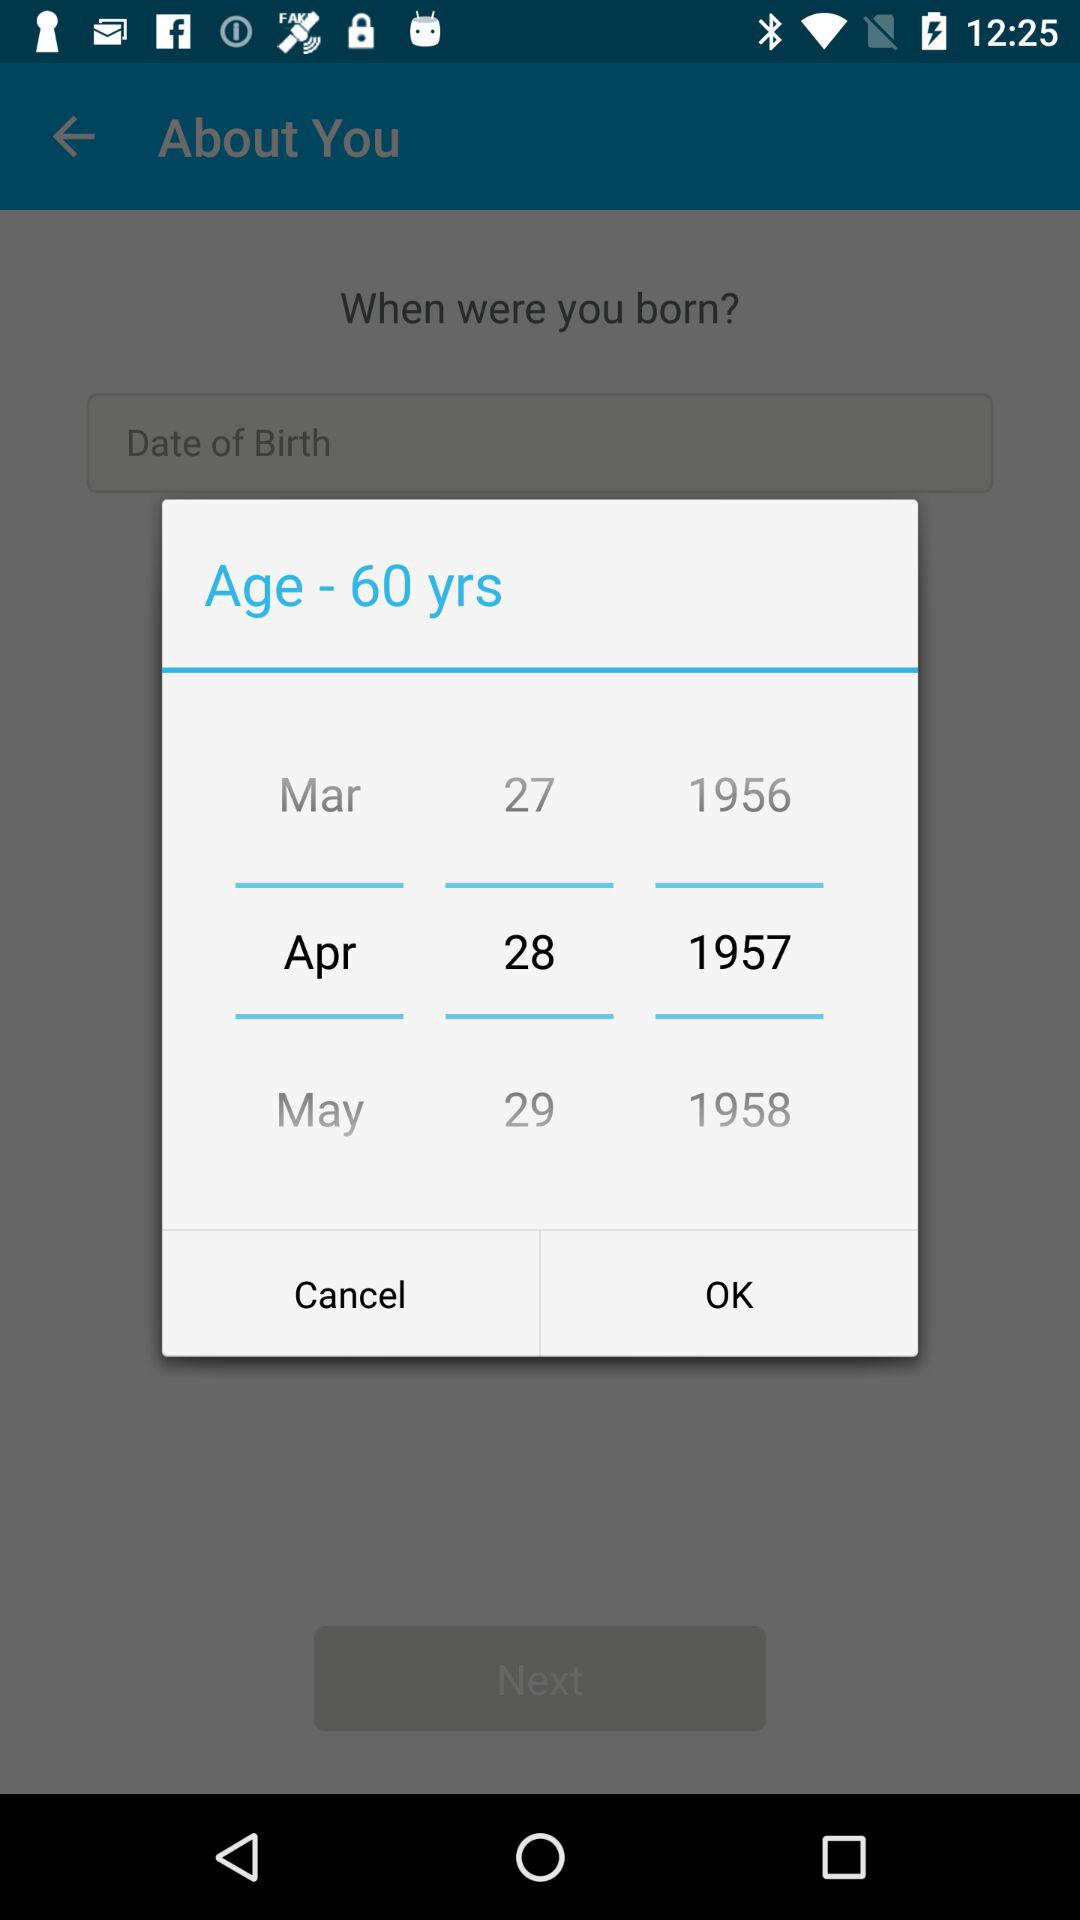How many years older is the person born in 1958 than the person born in 1956?
Answer the question using a single word or phrase. 2 